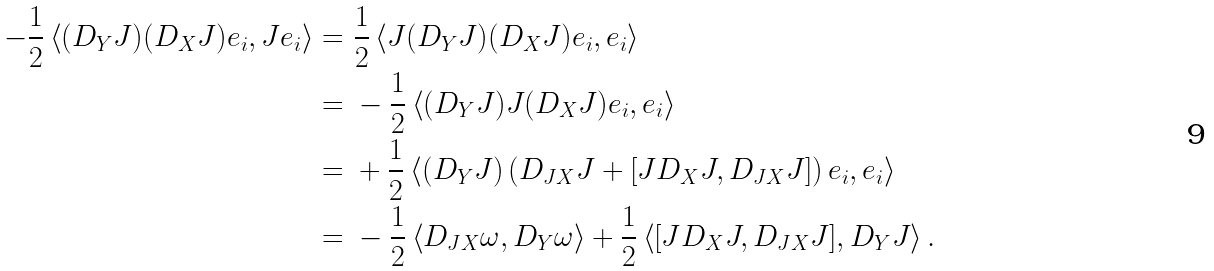Convert formula to latex. <formula><loc_0><loc_0><loc_500><loc_500>- \frac { 1 } { 2 } \left < ( D _ { Y } J ) ( D _ { X } J ) e _ { i } , J e _ { i } \right > = & \ \frac { 1 } { 2 } \left < J ( D _ { Y } J ) ( D _ { X } J ) e _ { i } , e _ { i } \right > \\ = & \ - \frac { 1 } { 2 } \left < ( D _ { Y } J ) J ( D _ { X } J ) e _ { i } , e _ { i } \right > \\ = & \ + \frac { 1 } { 2 } \left < ( D _ { Y } J ) \left ( D _ { J X } J + [ J D _ { X } J , D _ { J X } J ] \right ) e _ { i } , e _ { i } \right > \\ = & \ - \frac { 1 } { 2 } \left < D _ { J X } \omega , D _ { Y } \omega \right > + \frac { 1 } { 2 } \left < [ J D _ { X } J , D _ { J X } J ] , D _ { Y } J \right > .</formula> 